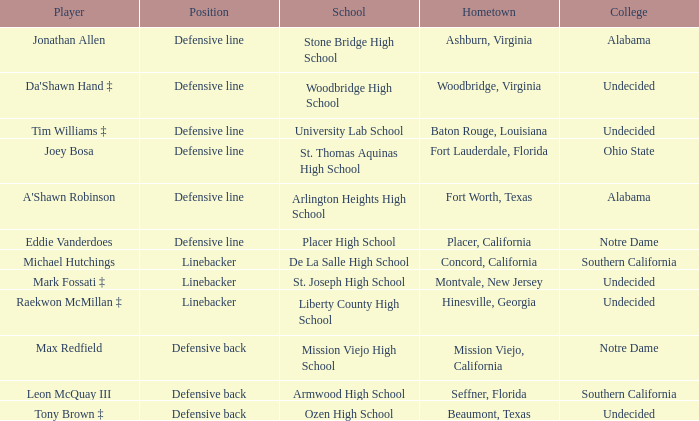Which university did the athlete from liberty county high school go to? Undecided. 